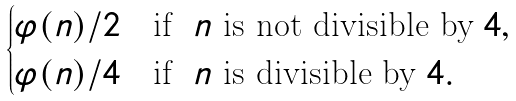Convert formula to latex. <formula><loc_0><loc_0><loc_500><loc_500>\begin{cases} \varphi ( n ) / 2 & \text {if} \ \ n \ \text {is not divisible by} \ 4 , \\ \varphi ( n ) / 4 & \text {if} \ \ n \ \text {is divisible by} \ 4 . \end{cases}</formula> 